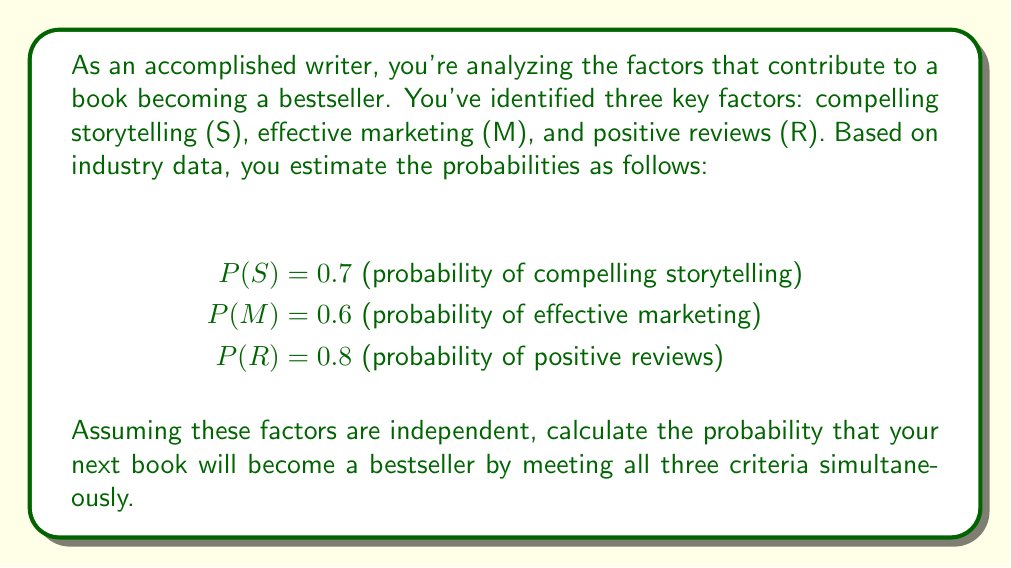Give your solution to this math problem. To solve this problem, we need to use the multiplication rule for independent events. Since we're assuming the factors are independent, we can multiply their individual probabilities to find the probability of all three occurring together.

Let B be the event that the book becomes a bestseller. We want to calculate:

$$P(B) = P(S \cap M \cap R)$$

Given the independence assumption, we can write:

$$P(B) = P(S) \times P(M) \times P(R)$$

Now, let's substitute the given probabilities:

$$P(B) = 0.7 \times 0.6 \times 0.8$$

Calculating:

$$P(B) = 0.336$$

To convert to a percentage:

$$0.336 \times 100\% = 33.6\%$$

Therefore, the probability that your next book will become a bestseller by meeting all three criteria is approximately 33.6%.
Answer: The probability that the book will become a bestseller is 0.336 or 33.6%. 